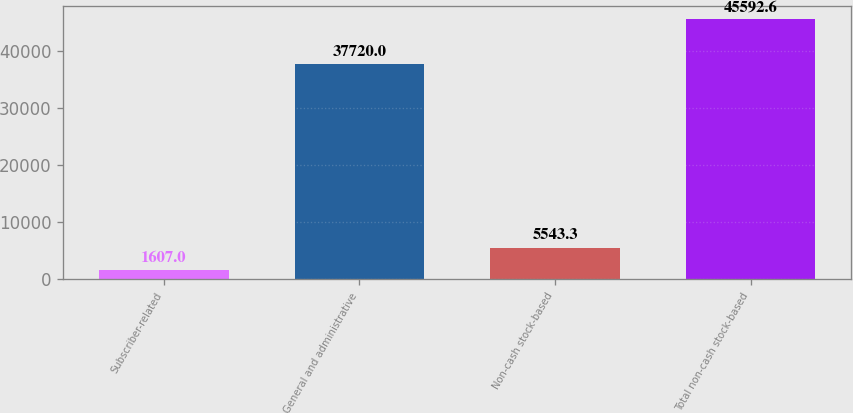<chart> <loc_0><loc_0><loc_500><loc_500><bar_chart><fcel>Subscriber-related<fcel>General and administrative<fcel>Non-cash stock-based<fcel>Total non-cash stock-based<nl><fcel>1607<fcel>37720<fcel>5543.3<fcel>45592.6<nl></chart> 